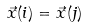<formula> <loc_0><loc_0><loc_500><loc_500>\vec { x } ( i ) = \vec { x } ( j )</formula> 